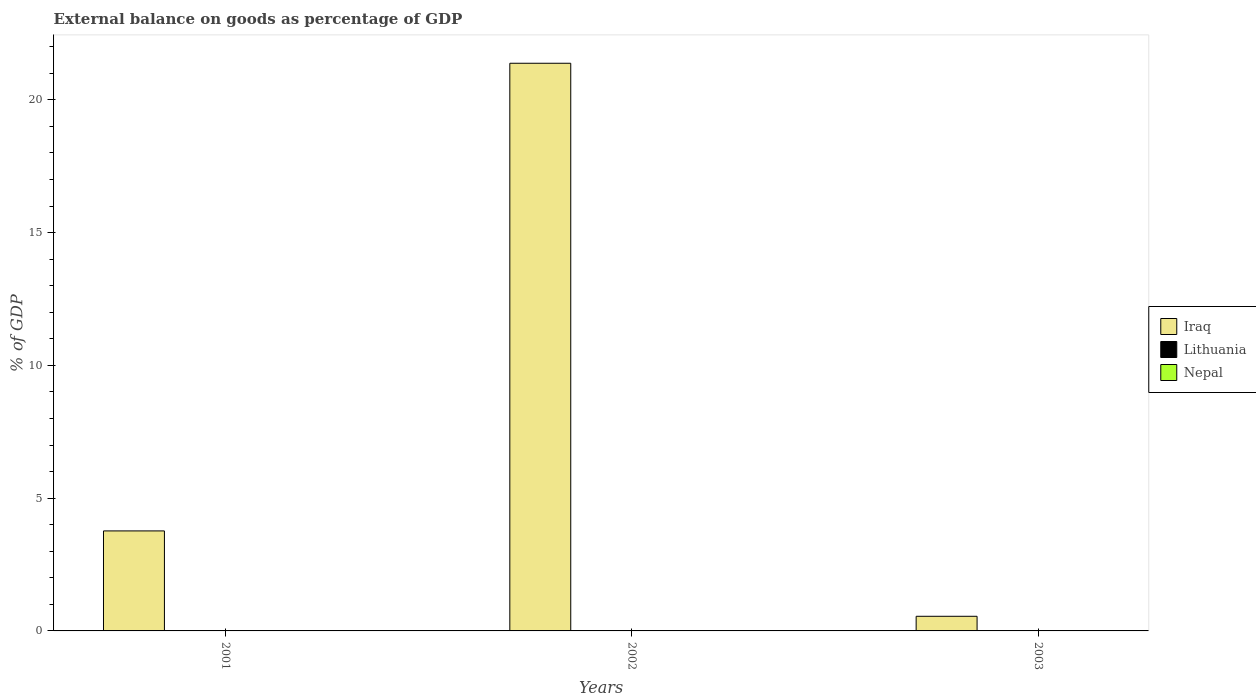Are the number of bars per tick equal to the number of legend labels?
Offer a terse response. No. Are the number of bars on each tick of the X-axis equal?
Give a very brief answer. Yes. How many bars are there on the 1st tick from the right?
Provide a succinct answer. 1. What is the external balance on goods as percentage of GDP in Iraq in 2001?
Offer a terse response. 3.77. Across all years, what is the maximum external balance on goods as percentage of GDP in Iraq?
Your answer should be compact. 21.38. Across all years, what is the minimum external balance on goods as percentage of GDP in Iraq?
Your response must be concise. 0.55. What is the total external balance on goods as percentage of GDP in Iraq in the graph?
Provide a short and direct response. 25.7. What is the difference between the external balance on goods as percentage of GDP in Iraq in 2001 and that in 2003?
Offer a terse response. 3.22. What is the difference between the external balance on goods as percentage of GDP in Lithuania in 2003 and the external balance on goods as percentage of GDP in Iraq in 2002?
Provide a short and direct response. -21.38. In how many years, is the external balance on goods as percentage of GDP in Nepal greater than 20 %?
Keep it short and to the point. 0. What is the ratio of the external balance on goods as percentage of GDP in Iraq in 2001 to that in 2002?
Offer a very short reply. 0.18. Is the external balance on goods as percentage of GDP in Iraq in 2002 less than that in 2003?
Provide a short and direct response. No. What is the difference between the highest and the second highest external balance on goods as percentage of GDP in Iraq?
Provide a succinct answer. 17.61. What is the difference between the highest and the lowest external balance on goods as percentage of GDP in Iraq?
Offer a very short reply. 20.83. Is it the case that in every year, the sum of the external balance on goods as percentage of GDP in Iraq and external balance on goods as percentage of GDP in Lithuania is greater than the external balance on goods as percentage of GDP in Nepal?
Your response must be concise. Yes. How many bars are there?
Offer a very short reply. 3. What is the difference between two consecutive major ticks on the Y-axis?
Your response must be concise. 5. Does the graph contain any zero values?
Make the answer very short. Yes. Does the graph contain grids?
Make the answer very short. No. How many legend labels are there?
Make the answer very short. 3. What is the title of the graph?
Keep it short and to the point. External balance on goods as percentage of GDP. What is the label or title of the X-axis?
Your response must be concise. Years. What is the label or title of the Y-axis?
Your answer should be compact. % of GDP. What is the % of GDP of Iraq in 2001?
Your answer should be compact. 3.77. What is the % of GDP of Nepal in 2001?
Your answer should be compact. 0. What is the % of GDP in Iraq in 2002?
Provide a succinct answer. 21.38. What is the % of GDP in Lithuania in 2002?
Keep it short and to the point. 0. What is the % of GDP in Nepal in 2002?
Make the answer very short. 0. What is the % of GDP of Iraq in 2003?
Offer a very short reply. 0.55. What is the % of GDP in Nepal in 2003?
Offer a very short reply. 0. Across all years, what is the maximum % of GDP of Iraq?
Ensure brevity in your answer.  21.38. Across all years, what is the minimum % of GDP of Iraq?
Your answer should be compact. 0.55. What is the total % of GDP in Iraq in the graph?
Your answer should be very brief. 25.7. What is the total % of GDP in Nepal in the graph?
Make the answer very short. 0. What is the difference between the % of GDP in Iraq in 2001 and that in 2002?
Offer a terse response. -17.61. What is the difference between the % of GDP of Iraq in 2001 and that in 2003?
Offer a very short reply. 3.22. What is the difference between the % of GDP in Iraq in 2002 and that in 2003?
Your answer should be compact. 20.83. What is the average % of GDP in Iraq per year?
Keep it short and to the point. 8.57. What is the average % of GDP of Nepal per year?
Ensure brevity in your answer.  0. What is the ratio of the % of GDP in Iraq in 2001 to that in 2002?
Your answer should be compact. 0.18. What is the ratio of the % of GDP in Iraq in 2001 to that in 2003?
Keep it short and to the point. 6.84. What is the ratio of the % of GDP of Iraq in 2002 to that in 2003?
Ensure brevity in your answer.  38.8. What is the difference between the highest and the second highest % of GDP in Iraq?
Provide a succinct answer. 17.61. What is the difference between the highest and the lowest % of GDP in Iraq?
Offer a terse response. 20.83. 